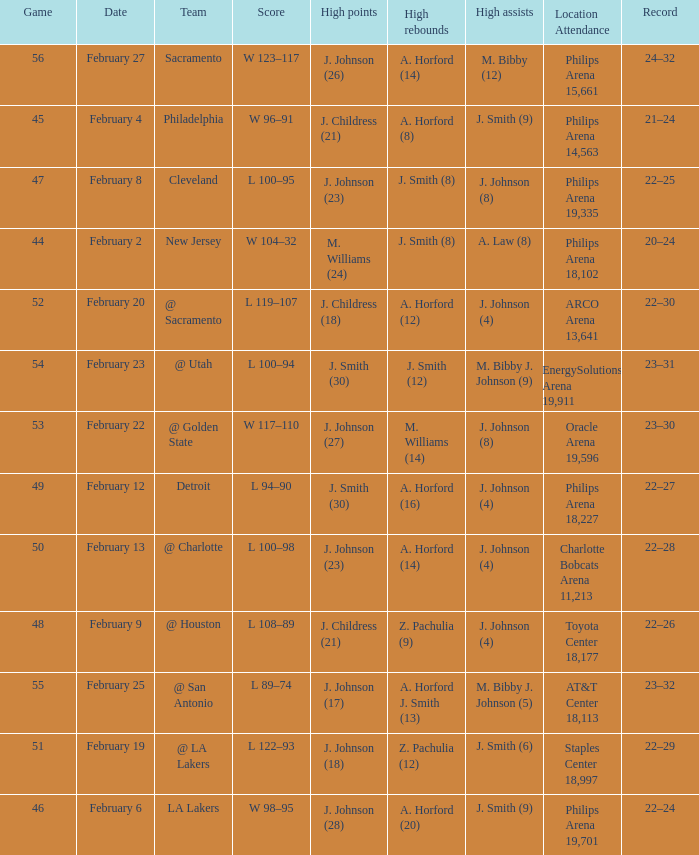What is the team located at philips arena 18,227? Detroit. 